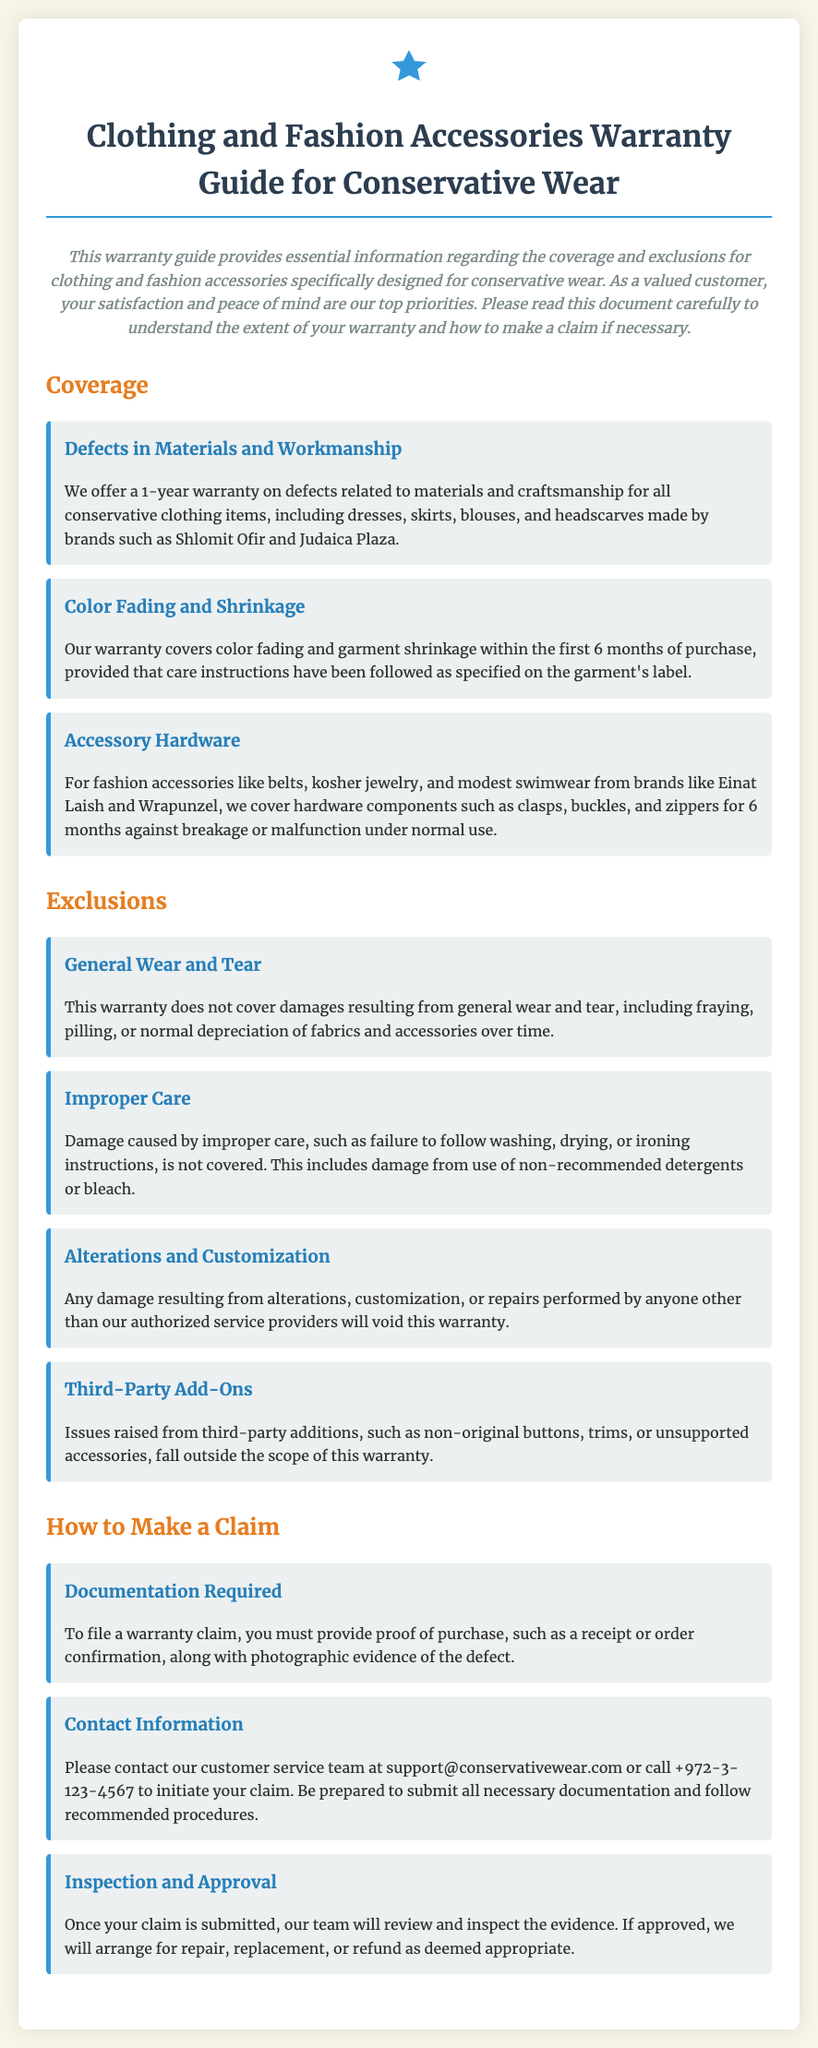What is the warranty duration for defects in materials and workmanship? The warranty duration for defects related to materials and craftsmanship for all conservative clothing items is 1 year.
Answer: 1 year What type of damages does the warranty cover for fashion accessories? The warranty covers hardware components such as clasps, buckles, and zippers for 6 months against breakage or malfunction under normal use.
Answer: Hardware components How long is the warranty coverage for color fading and shrinkage? The warranty covers color fading and garment shrinkage within the first 6 months of purchase.
Answer: 6 months What action will void the warranty concerning alterations? Any damage resulting from alterations, customization, or repairs performed by anyone other than our authorized service providers will void this warranty.
Answer: Unauthorized alterations What is required to file a warranty claim? To file a warranty claim, you must provide proof of purchase, such as a receipt or order confirmation, along with photographic evidence of the defect.
Answer: Proof of purchase and photographs What should you do to initiate a warranty claim? Please contact our customer service team at support@conservativewear.com or call +972-3-123-4567 to initiate your claim.
Answer: Contact customer service Which type of damages are excluded from the warranty? This warranty does not cover damages resulting from general wear and tear, including fraying, pilling, or normal depreciation of fabrics and accessories over time.
Answer: General wear and tear What is the warranty coverage for accessory hardware? The warranty covers accessory hardware for 6 months against breakage or malfunction under normal use.
Answer: 6 months 